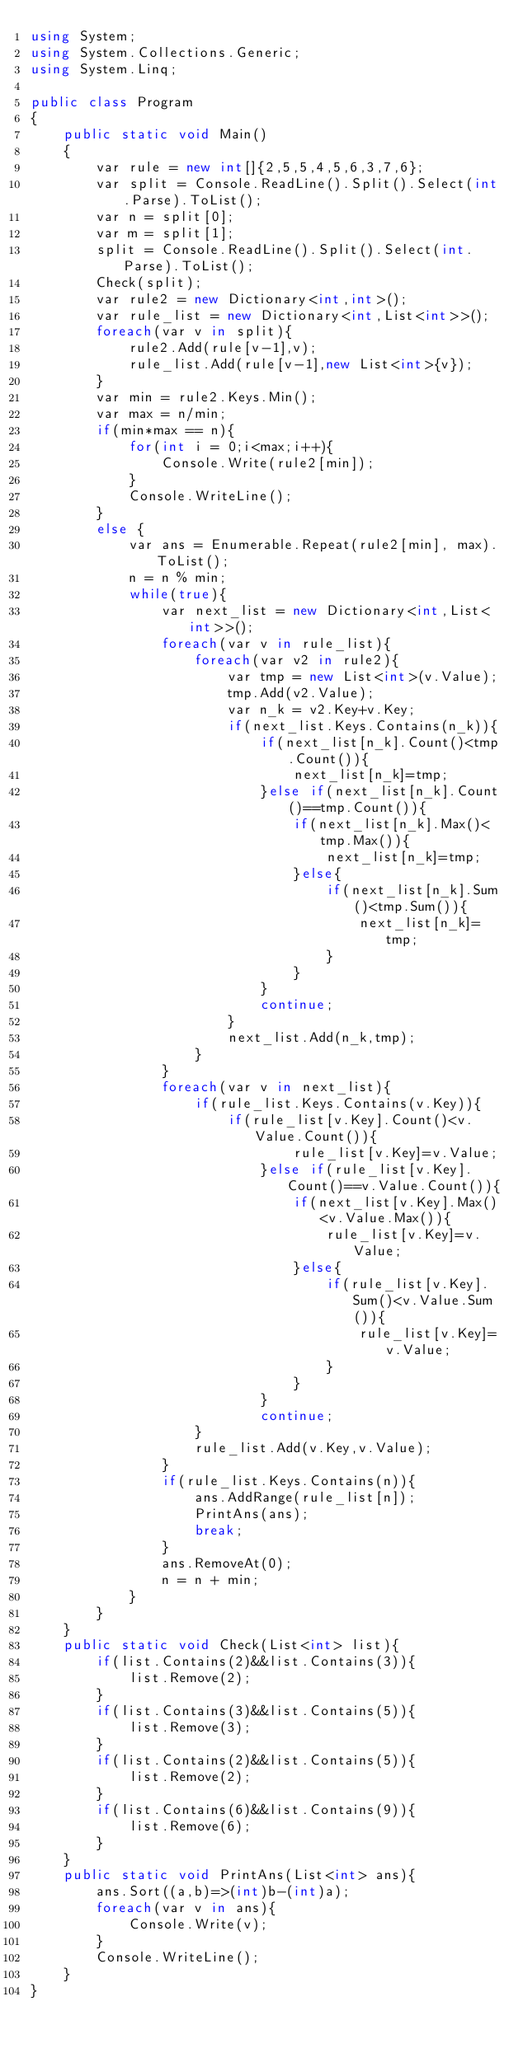Convert code to text. <code><loc_0><loc_0><loc_500><loc_500><_C#_>using System;
using System.Collections.Generic;
using System.Linq;
 
public class Program
{
	public static void Main()
	{
		var rule = new int[]{2,5,5,4,5,6,3,7,6};
		var split = Console.ReadLine().Split().Select(int.Parse).ToList();
		var n = split[0];
		var m = split[1];
		split = Console.ReadLine().Split().Select(int.Parse).ToList();
		Check(split);
		var rule2 = new Dictionary<int,int>();
		var rule_list = new Dictionary<int,List<int>>();
		foreach(var v in split){
			rule2.Add(rule[v-1],v);
			rule_list.Add(rule[v-1],new List<int>{v});
		}
		var min = rule2.Keys.Min();
		var max = n/min;
		if(min*max == n){
			for(int i = 0;i<max;i++){
				Console.Write(rule2[min]);
			}
			Console.WriteLine();
		}
		else {
			var ans = Enumerable.Repeat(rule2[min], max).ToList();
			n = n % min;
			while(true){
				var next_list = new Dictionary<int,List<int>>();
				foreach(var v in rule_list){
					foreach(var v2 in rule2){
						var tmp = new List<int>(v.Value);
						tmp.Add(v2.Value);
						var n_k = v2.Key+v.Key;
						if(next_list.Keys.Contains(n_k)){
							if(next_list[n_k].Count()<tmp.Count()){
								next_list[n_k]=tmp;
							}else if(next_list[n_k].Count()==tmp.Count()){
								if(next_list[n_k].Max()<tmp.Max()){
									next_list[n_k]=tmp;
								}else{
									if(next_list[n_k].Sum()<tmp.Sum()){
										next_list[n_k]=tmp;
									}
								}
							}
							continue;
						}
						next_list.Add(n_k,tmp);
					}
				}
				foreach(var v in next_list){
					if(rule_list.Keys.Contains(v.Key)){
						if(rule_list[v.Key].Count()<v.Value.Count()){
								rule_list[v.Key]=v.Value;
							}else if(rule_list[v.Key].Count()==v.Value.Count()){
								if(next_list[v.Key].Max()<v.Value.Max()){
									rule_list[v.Key]=v.Value;
								}else{
									if(rule_list[v.Key].Sum()<v.Value.Sum()){
										rule_list[v.Key]=v.Value;
									}
								}
							}
							continue;
					}
					rule_list.Add(v.Key,v.Value);
				}
				if(rule_list.Keys.Contains(n)){
					ans.AddRange(rule_list[n]);
					PrintAns(ans);
					break;
				}
				ans.RemoveAt(0);
				n = n + min;
			}
		}
	}
	public static void Check(List<int> list){
		if(list.Contains(2)&&list.Contains(3)){
			list.Remove(2);
		}
		if(list.Contains(3)&&list.Contains(5)){
			list.Remove(3);
		}
		if(list.Contains(2)&&list.Contains(5)){
			list.Remove(2);
		}
		if(list.Contains(6)&&list.Contains(9)){
			list.Remove(6);
		}
	}
	public static void PrintAns(List<int> ans){
		ans.Sort((a,b)=>(int)b-(int)a);
		foreach(var v in ans){
			Console.Write(v);
		}
		Console.WriteLine();
	}
}
</code> 